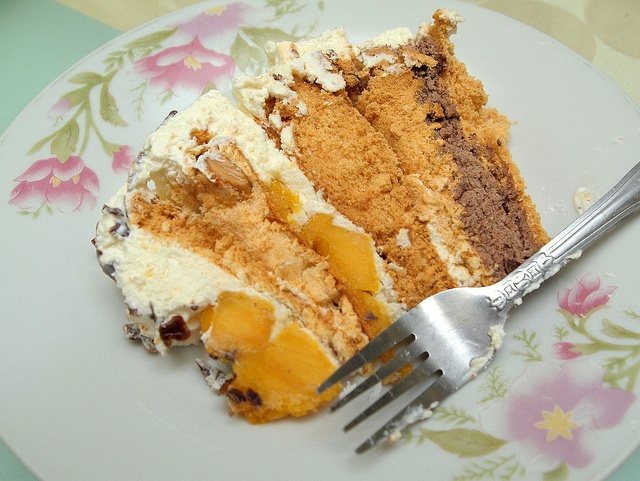Describe the objects in this image and their specific colors. I can see cake in gray, tan, red, and orange tones and fork in gray, darkgray, and lightgray tones in this image. 